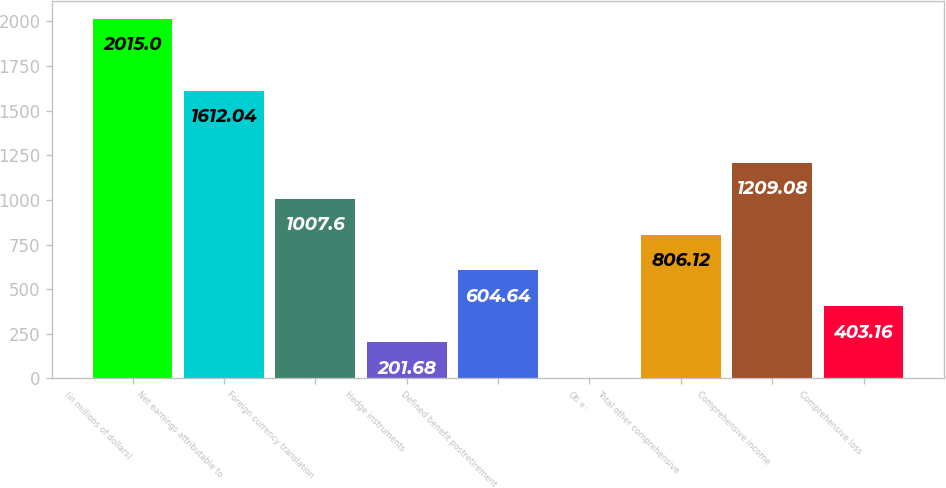Convert chart to OTSL. <chart><loc_0><loc_0><loc_500><loc_500><bar_chart><fcel>(in millions of dollars)<fcel>Net earnings attributable to<fcel>Foreign currency translation<fcel>Hedge instruments<fcel>Defined benefit postretirement<fcel>Other<fcel>Total other comprehensive<fcel>Comprehensive income<fcel>Comprehensive loss<nl><fcel>2015<fcel>1612.04<fcel>1007.6<fcel>201.68<fcel>604.64<fcel>0.2<fcel>806.12<fcel>1209.08<fcel>403.16<nl></chart> 